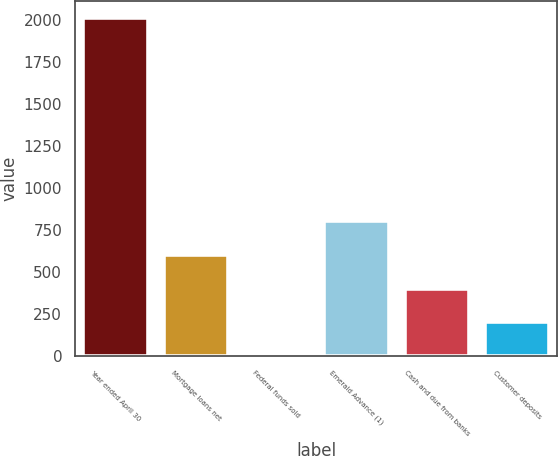<chart> <loc_0><loc_0><loc_500><loc_500><bar_chart><fcel>Year ended April 30<fcel>Mortgage loans net<fcel>Federal funds sold<fcel>Emerald Advance (1)<fcel>Cash and due from banks<fcel>Customer deposits<nl><fcel>2012<fcel>603.64<fcel>0.04<fcel>804.84<fcel>402.44<fcel>201.24<nl></chart> 